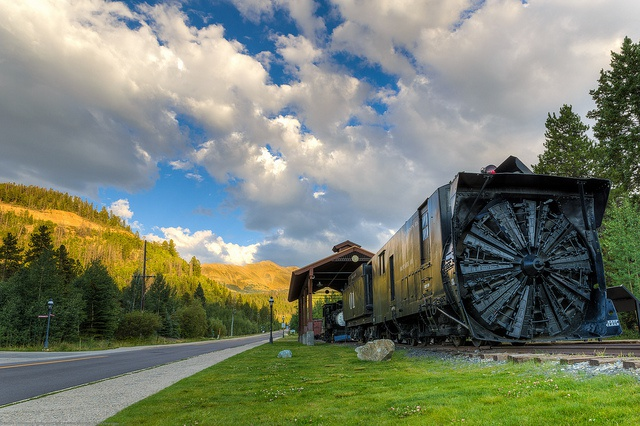Describe the objects in this image and their specific colors. I can see a train in beige, black, blue, gray, and darkgreen tones in this image. 